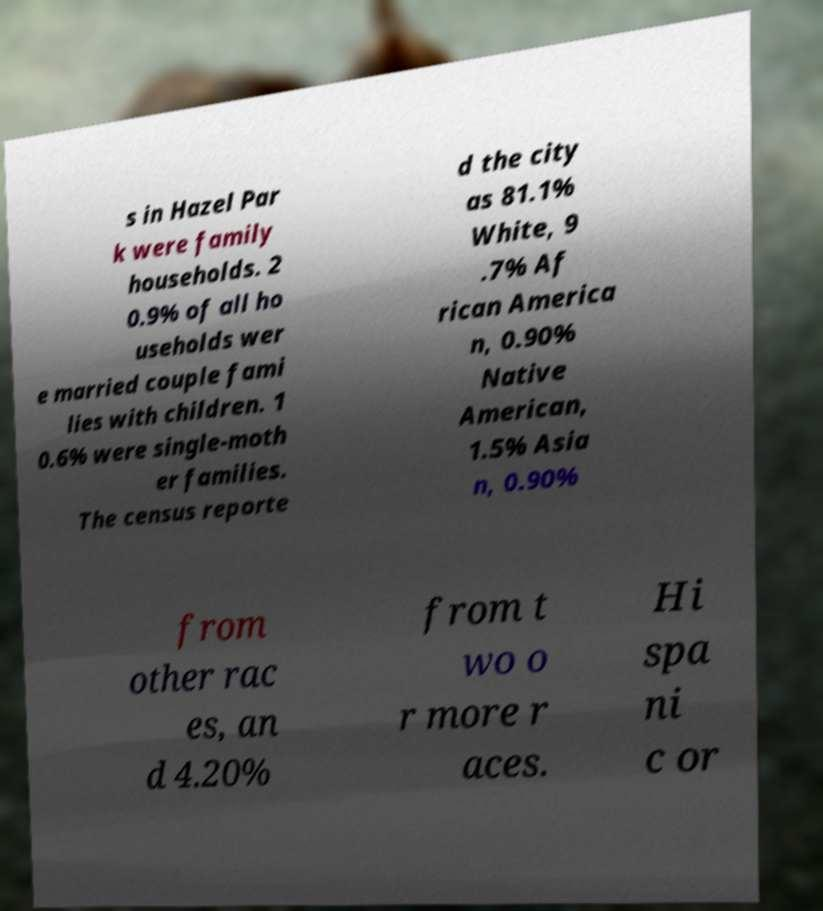I need the written content from this picture converted into text. Can you do that? s in Hazel Par k were family households. 2 0.9% of all ho useholds wer e married couple fami lies with children. 1 0.6% were single-moth er families. The census reporte d the city as 81.1% White, 9 .7% Af rican America n, 0.90% Native American, 1.5% Asia n, 0.90% from other rac es, an d 4.20% from t wo o r more r aces. Hi spa ni c or 